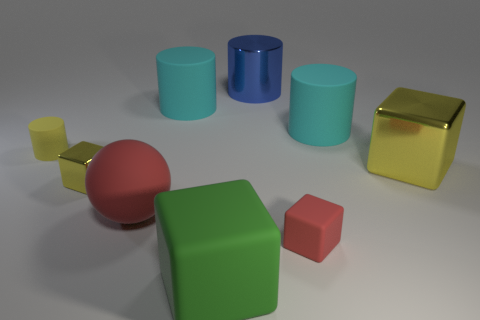Subtract all purple spheres. How many yellow blocks are left? 2 Add 1 red matte objects. How many objects exist? 10 Subtract all green blocks. How many blocks are left? 3 Subtract all tiny rubber cubes. How many cubes are left? 3 Subtract all blue cubes. Subtract all blue spheres. How many cubes are left? 4 Subtract all cylinders. How many objects are left? 5 Add 5 big yellow metallic cubes. How many big yellow metallic cubes exist? 6 Subtract 0 yellow spheres. How many objects are left? 9 Subtract all small brown metal cubes. Subtract all big cyan cylinders. How many objects are left? 7 Add 6 small matte objects. How many small matte objects are left? 8 